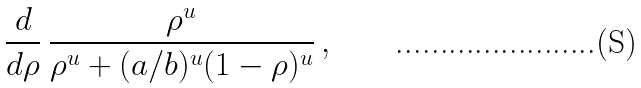Convert formula to latex. <formula><loc_0><loc_0><loc_500><loc_500>\frac { d } { d \rho } \, \frac { \rho ^ { u } } { \rho ^ { u } + ( a / b ) ^ { u } ( 1 - \rho ) ^ { u } } \, ,</formula> 